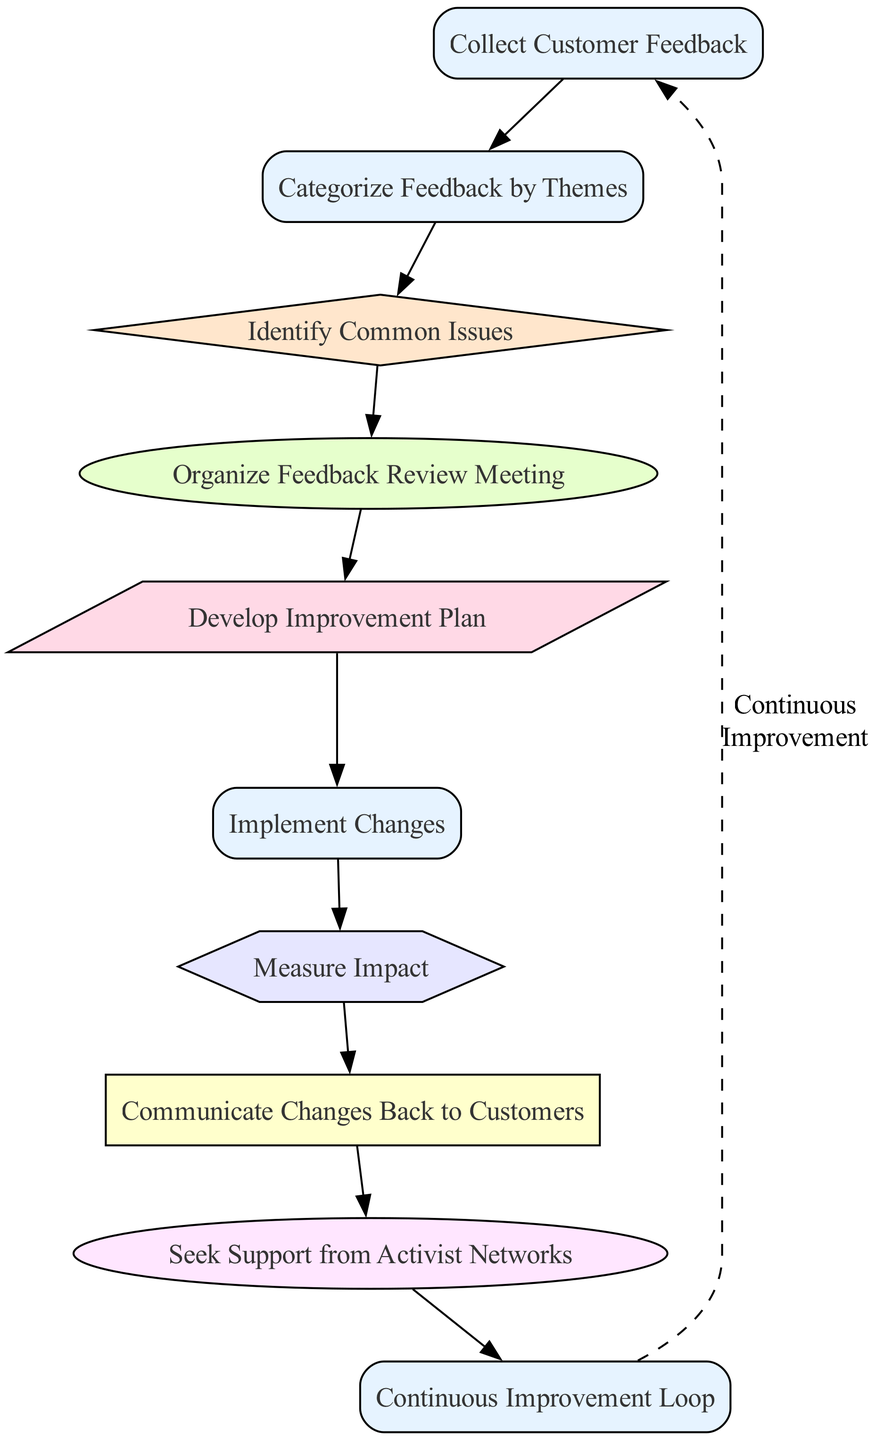What is the first step in the process? The first node in the diagram is "Collect Customer Feedback," which initiates the process of receiving customer insights.
Answer: Collect Customer Feedback How many nodes are categorized as 'process'? The diagram shows several nodes, and upon inspection, there are four nodes specifically marked as 'process' types: "Collect Customer Feedback," "Implement Changes," "Communicate Changes Back to Customers," and "Continuous Improvement Loop."
Answer: Four Which node follows 'Identify Common Issues'? In the sequential flow of the diagram, the node that comes immediately after 'Identify Common Issues' is 'Organize Feedback Review Meeting'.
Answer: Organize Feedback Review Meeting What type of node is 'Seek Support from Activist Networks'? Upon reviewing the diagram, 'Seek Support from Activist Networks' is classified as a 'support' type, indicating its focus on obtaining help and guidance.
Answer: Support How does 'Implement Changes' relate to 'Measure Impact'? The diagram shows a direct flow where 'Implement Changes' leads to 'Measure Impact', indicating that measuring the effectiveness of the changes is a step that follows after implementation.
Answer: Directly leads to Which types of nodes are present in the diagram? By analyzing the nodes within the diagram, the types present include 'process', 'analysis', 'collaboration', 'planning', 'evaluation', 'communication', and 'support'.
Answer: Seven types What are the last two steps in the continuous improvement loop? The final two steps in the loop are 'Communicate Changes Back to Customers' and 'Seek Support from Activist Networks' before returning to 'Collect Customer Feedback'. This indicates a cycle of ongoing feedback and improvement.
Answer: Communicate Changes Back to Customers, Seek Support from Activist Networks How does the diagram support gender considerations? The diagram explicitly includes the step 'Organize Feedback Review Meeting', which highlights the importance of diverse perspectives, including gender considerations, during the feedback review process.
Answer: Diverse perspectives What is the connection between 'Develop Improvement Plan' and 'Implement Changes'? The flow indicates that 'Implement Changes' directly follows 'Develop Improvement Plan', highlighting that executing the plan is the next logical step after its development.
Answer: Direct connection 